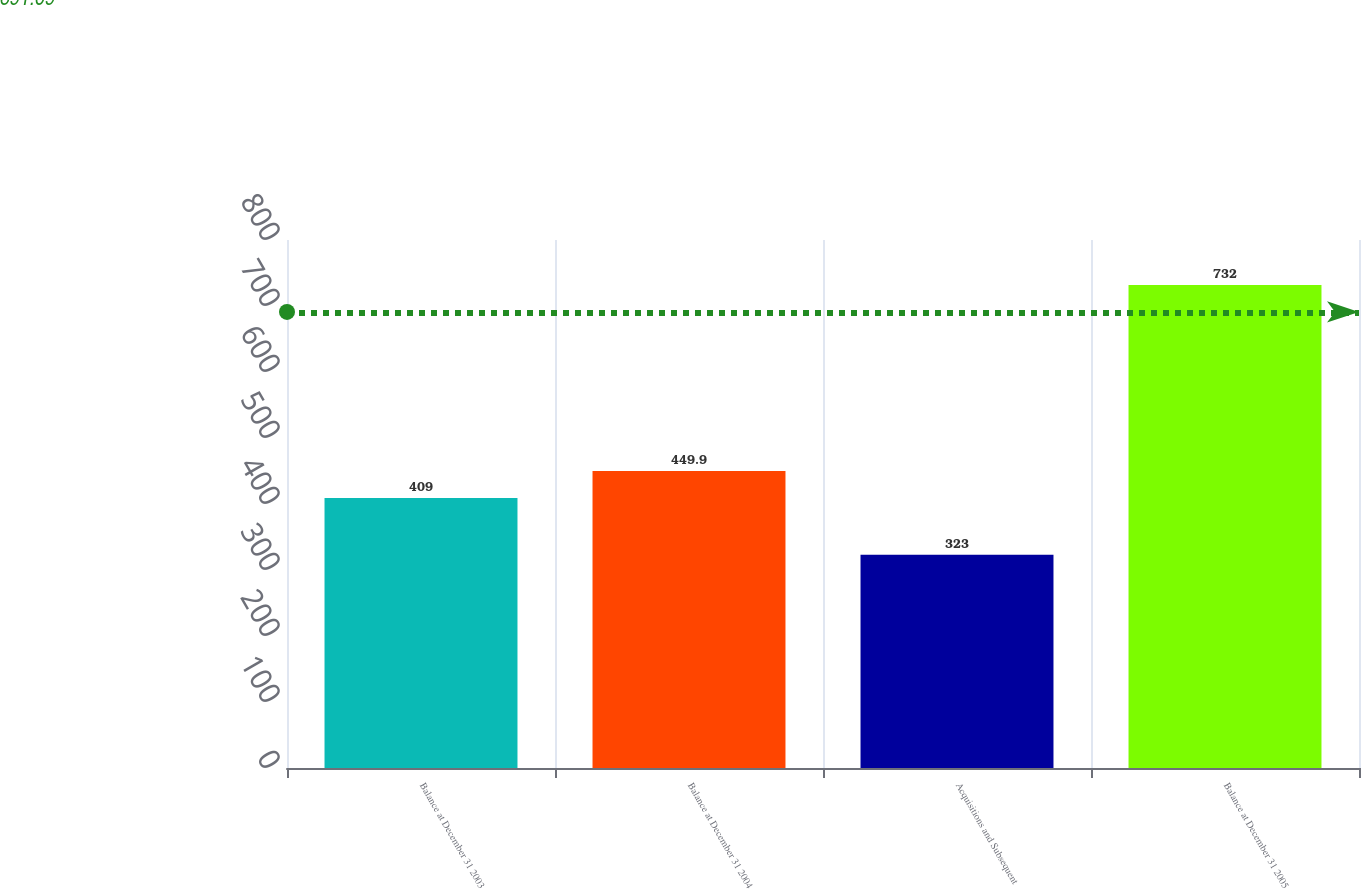Convert chart to OTSL. <chart><loc_0><loc_0><loc_500><loc_500><bar_chart><fcel>Balance at December 31 2003<fcel>Balance at December 31 2004<fcel>Acquisitions and Subsequent<fcel>Balance at December 31 2005<nl><fcel>409<fcel>449.9<fcel>323<fcel>732<nl></chart> 